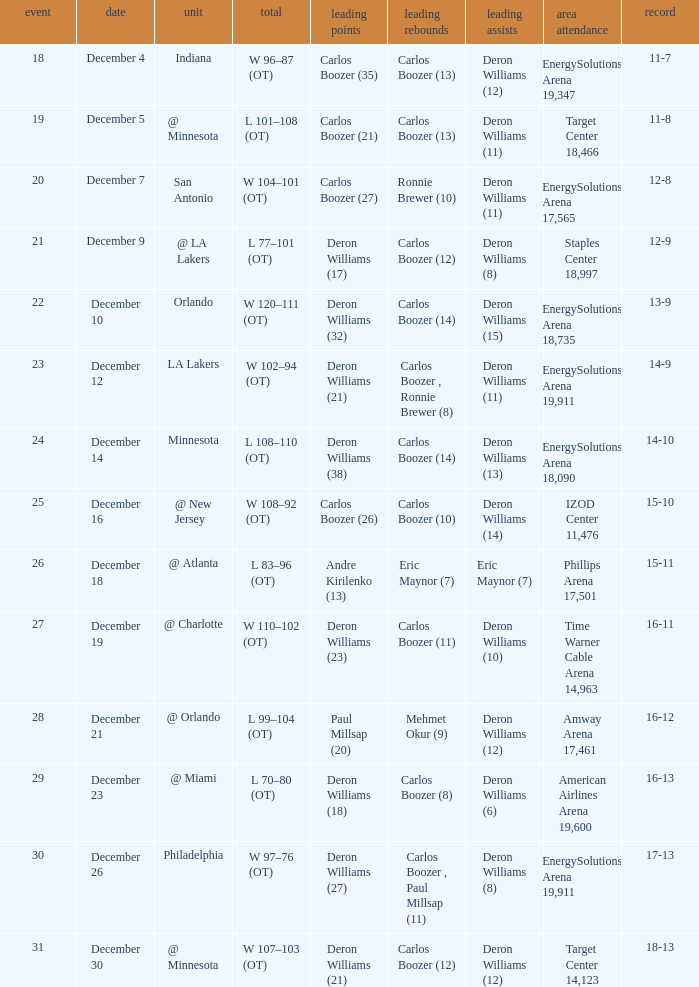What's the number of the game in which Carlos Boozer (8) did the high rebounds? 29.0. 